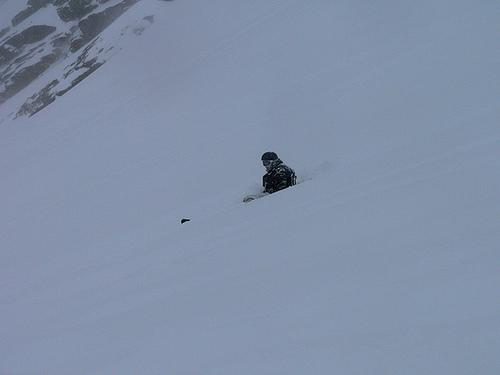Is he competing?
Keep it brief. No. Is the man cold?
Quick response, please. Yes. Is the guy in the air?
Quick response, please. No. Is there snow?
Quick response, please. Yes. How many birds are there?
Write a very short answer. 0. Is this man skiing?
Give a very brief answer. No. 